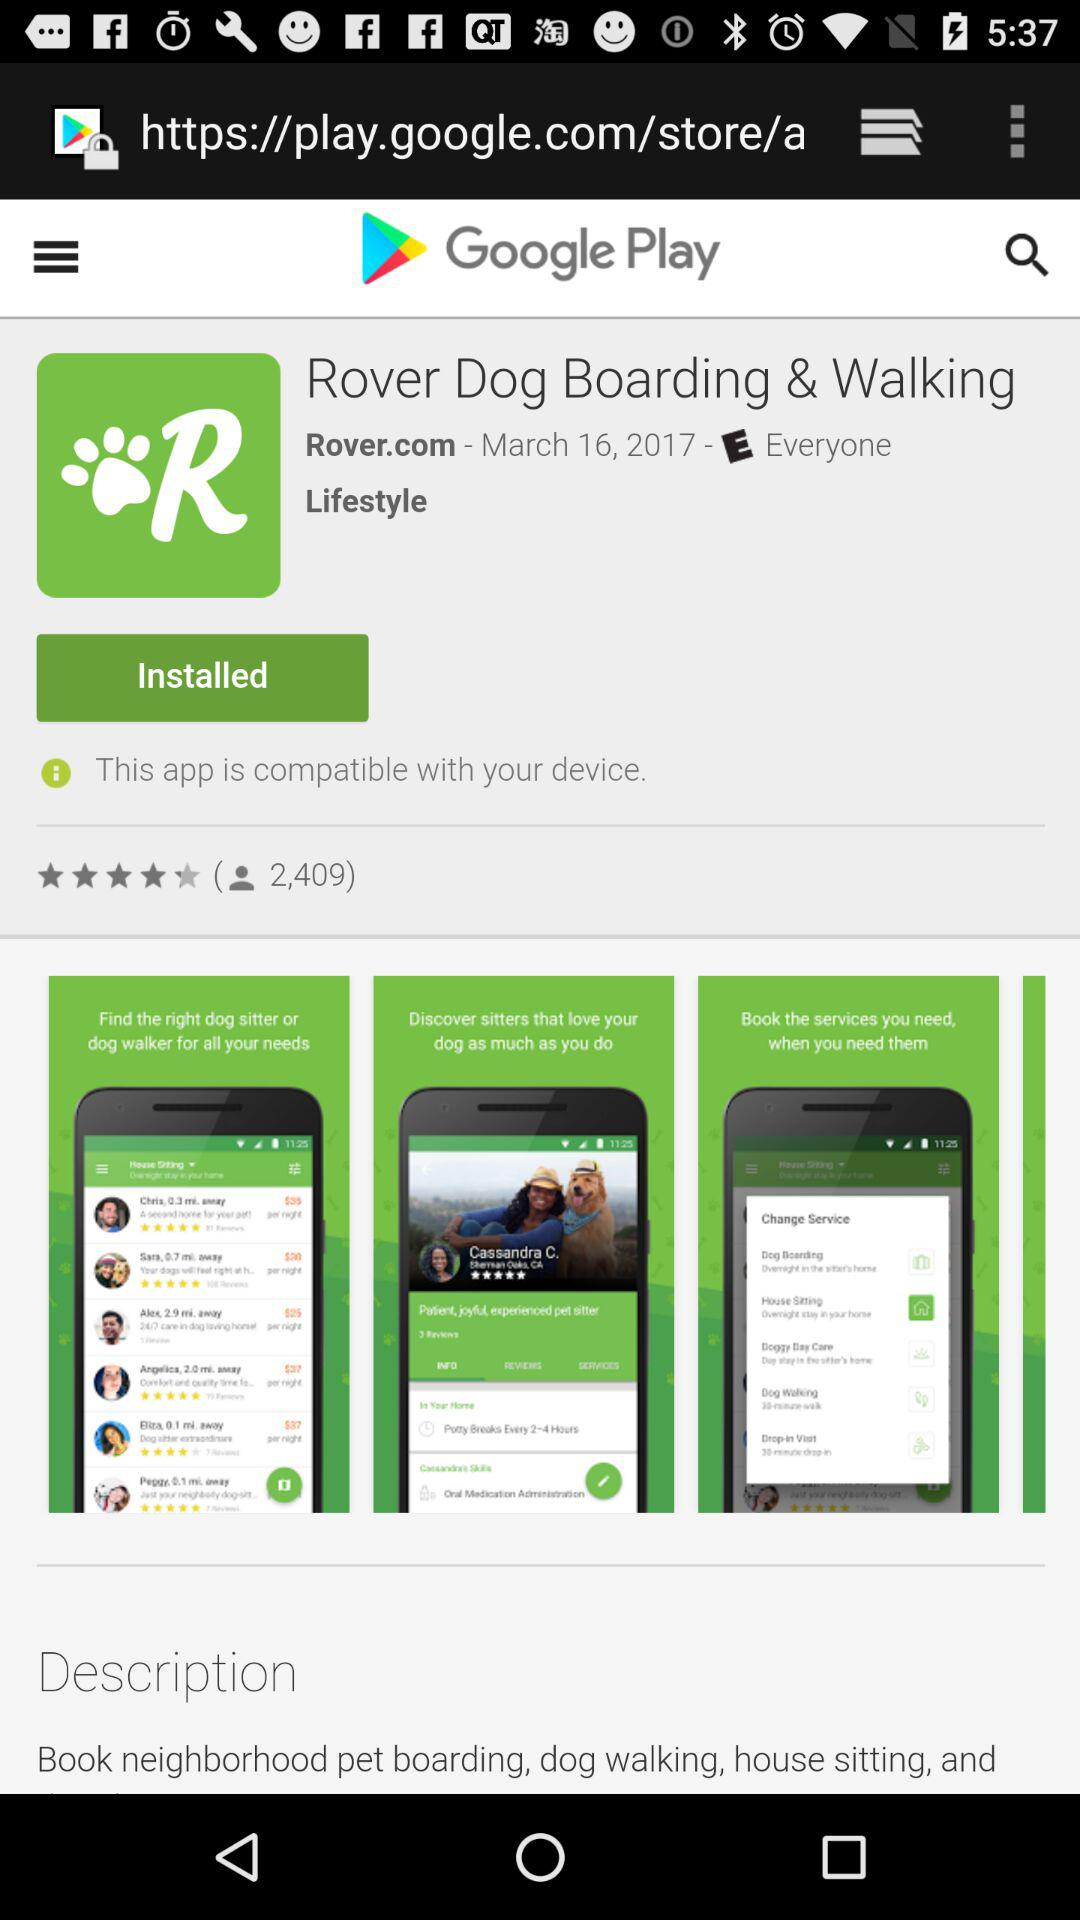How many users have rated it? There are 2,409 users who rated it. 